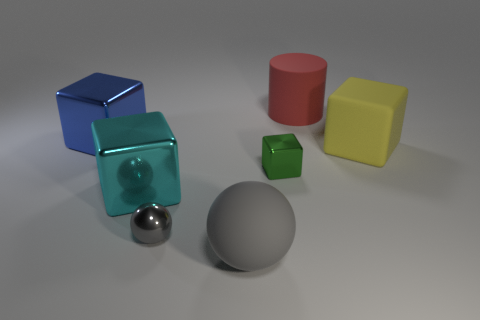Add 3 metal balls. How many objects exist? 10 Subtract all cylinders. How many objects are left? 6 Add 2 red rubber objects. How many red rubber objects are left? 3 Add 6 gray objects. How many gray objects exist? 8 Subtract 0 red balls. How many objects are left? 7 Subtract all shiny spheres. Subtract all yellow matte blocks. How many objects are left? 5 